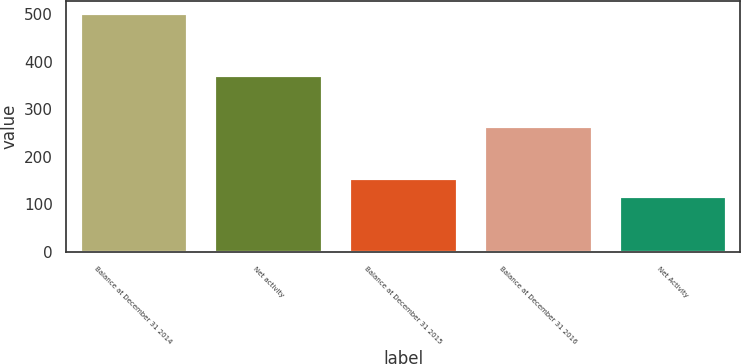Convert chart to OTSL. <chart><loc_0><loc_0><loc_500><loc_500><bar_chart><fcel>Balance at December 31 2014<fcel>Net activity<fcel>Balance at December 31 2015<fcel>Balance at December 31 2016<fcel>Net Activity<nl><fcel>503<fcel>373<fcel>155.6<fcel>265<fcel>117<nl></chart> 